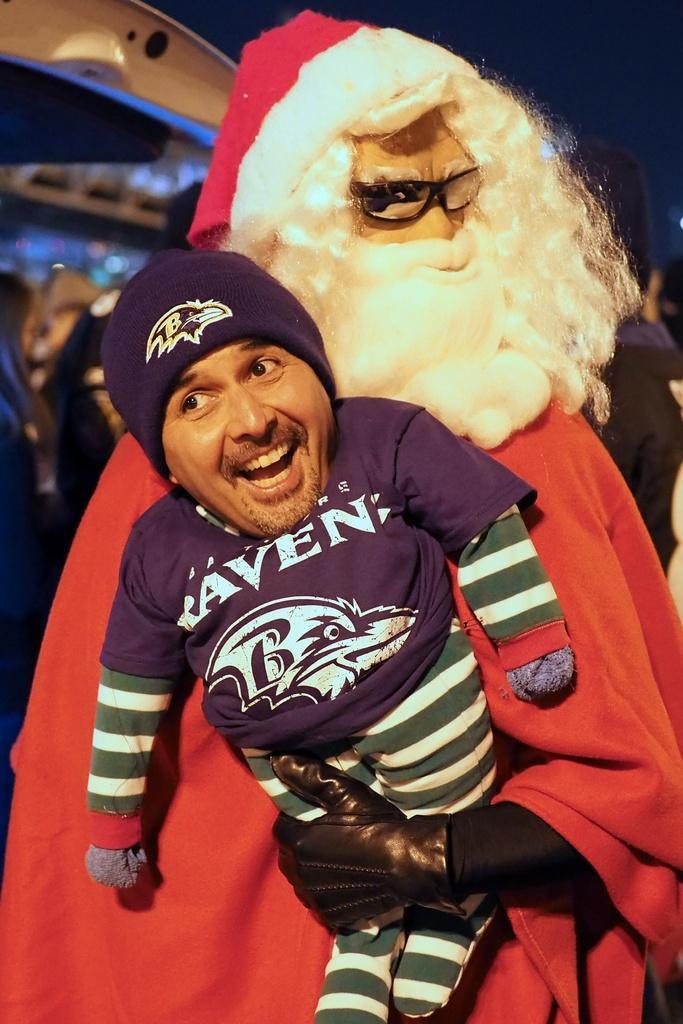Could you give a brief overview of what you see in this image? In the picture I can see a person in the Santa costume and the person is holding the toy in his hands. The toy face is covered with a man's smiley face. 